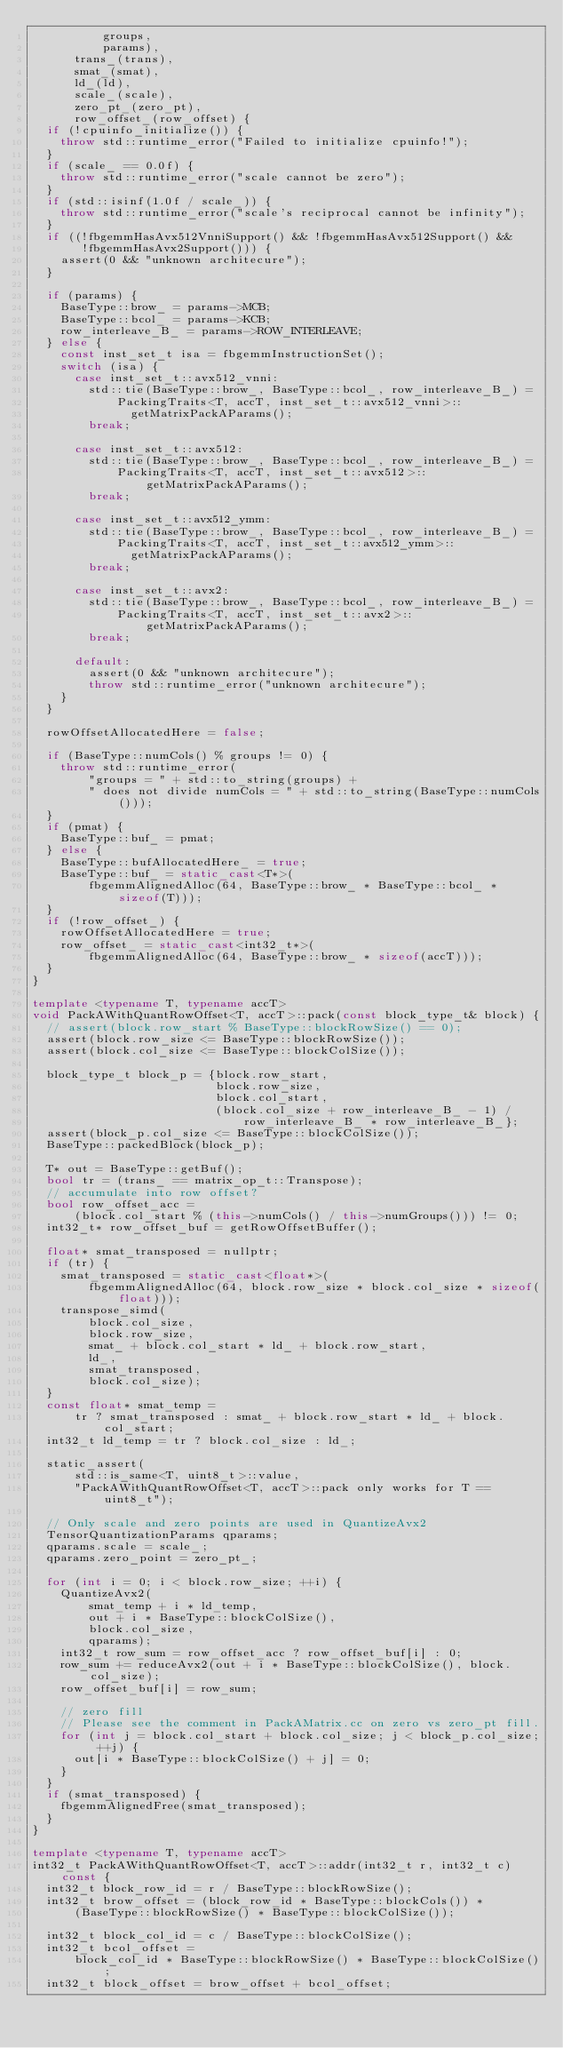<code> <loc_0><loc_0><loc_500><loc_500><_C++_>          groups,
          params),
      trans_(trans),
      smat_(smat),
      ld_(ld),
      scale_(scale),
      zero_pt_(zero_pt),
      row_offset_(row_offset) {
  if (!cpuinfo_initialize()) {
    throw std::runtime_error("Failed to initialize cpuinfo!");
  }
  if (scale_ == 0.0f) {
    throw std::runtime_error("scale cannot be zero");
  }
  if (std::isinf(1.0f / scale_)) {
    throw std::runtime_error("scale's reciprocal cannot be infinity");
  }
  if ((!fbgemmHasAvx512VnniSupport() && !fbgemmHasAvx512Support() &&
       !fbgemmHasAvx2Support())) {
    assert(0 && "unknown architecure");
  }

  if (params) {
    BaseType::brow_ = params->MCB;
    BaseType::bcol_ = params->KCB;
    row_interleave_B_ = params->ROW_INTERLEAVE;
  } else {
    const inst_set_t isa = fbgemmInstructionSet();
    switch (isa) {
      case inst_set_t::avx512_vnni:
        std::tie(BaseType::brow_, BaseType::bcol_, row_interleave_B_) =
            PackingTraits<T, accT, inst_set_t::avx512_vnni>::
              getMatrixPackAParams();
        break;

      case inst_set_t::avx512:
        std::tie(BaseType::brow_, BaseType::bcol_, row_interleave_B_) =
            PackingTraits<T, accT, inst_set_t::avx512>::getMatrixPackAParams();
        break;

      case inst_set_t::avx512_ymm:
        std::tie(BaseType::brow_, BaseType::bcol_, row_interleave_B_) =
            PackingTraits<T, accT, inst_set_t::avx512_ymm>::
              getMatrixPackAParams();
        break;

      case inst_set_t::avx2:
        std::tie(BaseType::brow_, BaseType::bcol_, row_interleave_B_) =
            PackingTraits<T, accT, inst_set_t::avx2>::getMatrixPackAParams();
        break;

      default:
        assert(0 && "unknown architecure");
        throw std::runtime_error("unknown architecure");
    }
  }

  rowOffsetAllocatedHere = false;

  if (BaseType::numCols() % groups != 0) {
    throw std::runtime_error(
        "groups = " + std::to_string(groups) +
        " does not divide numCols = " + std::to_string(BaseType::numCols()));
  }
  if (pmat) {
    BaseType::buf_ = pmat;
  } else {
    BaseType::bufAllocatedHere_ = true;
    BaseType::buf_ = static_cast<T*>(
        fbgemmAlignedAlloc(64, BaseType::brow_ * BaseType::bcol_ * sizeof(T)));
  }
  if (!row_offset_) {
    rowOffsetAllocatedHere = true;
    row_offset_ = static_cast<int32_t*>(
        fbgemmAlignedAlloc(64, BaseType::brow_ * sizeof(accT)));
  }
}

template <typename T, typename accT>
void PackAWithQuantRowOffset<T, accT>::pack(const block_type_t& block) {
  // assert(block.row_start % BaseType::blockRowSize() == 0);
  assert(block.row_size <= BaseType::blockRowSize());
  assert(block.col_size <= BaseType::blockColSize());

  block_type_t block_p = {block.row_start,
                          block.row_size,
                          block.col_start,
                          (block.col_size + row_interleave_B_ - 1) /
                              row_interleave_B_ * row_interleave_B_};
  assert(block_p.col_size <= BaseType::blockColSize());
  BaseType::packedBlock(block_p);

  T* out = BaseType::getBuf();
  bool tr = (trans_ == matrix_op_t::Transpose);
  // accumulate into row offset?
  bool row_offset_acc =
      (block.col_start % (this->numCols() / this->numGroups())) != 0;
  int32_t* row_offset_buf = getRowOffsetBuffer();

  float* smat_transposed = nullptr;
  if (tr) {
    smat_transposed = static_cast<float*>(
        fbgemmAlignedAlloc(64, block.row_size * block.col_size * sizeof(float)));
    transpose_simd(
        block.col_size,
        block.row_size,
        smat_ + block.col_start * ld_ + block.row_start,
        ld_,
        smat_transposed,
        block.col_size);
  }
  const float* smat_temp =
      tr ? smat_transposed : smat_ + block.row_start * ld_ + block.col_start;
  int32_t ld_temp = tr ? block.col_size : ld_;

  static_assert(
      std::is_same<T, uint8_t>::value,
      "PackAWithQuantRowOffset<T, accT>::pack only works for T == uint8_t");

  // Only scale and zero points are used in QuantizeAvx2
  TensorQuantizationParams qparams;
  qparams.scale = scale_;
  qparams.zero_point = zero_pt_;

  for (int i = 0; i < block.row_size; ++i) {
    QuantizeAvx2(
        smat_temp + i * ld_temp,
        out + i * BaseType::blockColSize(),
        block.col_size,
        qparams);
    int32_t row_sum = row_offset_acc ? row_offset_buf[i] : 0;
    row_sum += reduceAvx2(out + i * BaseType::blockColSize(), block.col_size);
    row_offset_buf[i] = row_sum;

    // zero fill
    // Please see the comment in PackAMatrix.cc on zero vs zero_pt fill.
    for (int j = block.col_start + block.col_size; j < block_p.col_size; ++j) {
      out[i * BaseType::blockColSize() + j] = 0;
    }
  }
  if (smat_transposed) {
    fbgemmAlignedFree(smat_transposed);
  }
}

template <typename T, typename accT>
int32_t PackAWithQuantRowOffset<T, accT>::addr(int32_t r, int32_t c) const {
  int32_t block_row_id = r / BaseType::blockRowSize();
  int32_t brow_offset = (block_row_id * BaseType::blockCols()) *
      (BaseType::blockRowSize() * BaseType::blockColSize());

  int32_t block_col_id = c / BaseType::blockColSize();
  int32_t bcol_offset =
      block_col_id * BaseType::blockRowSize() * BaseType::blockColSize();
  int32_t block_offset = brow_offset + bcol_offset;</code> 